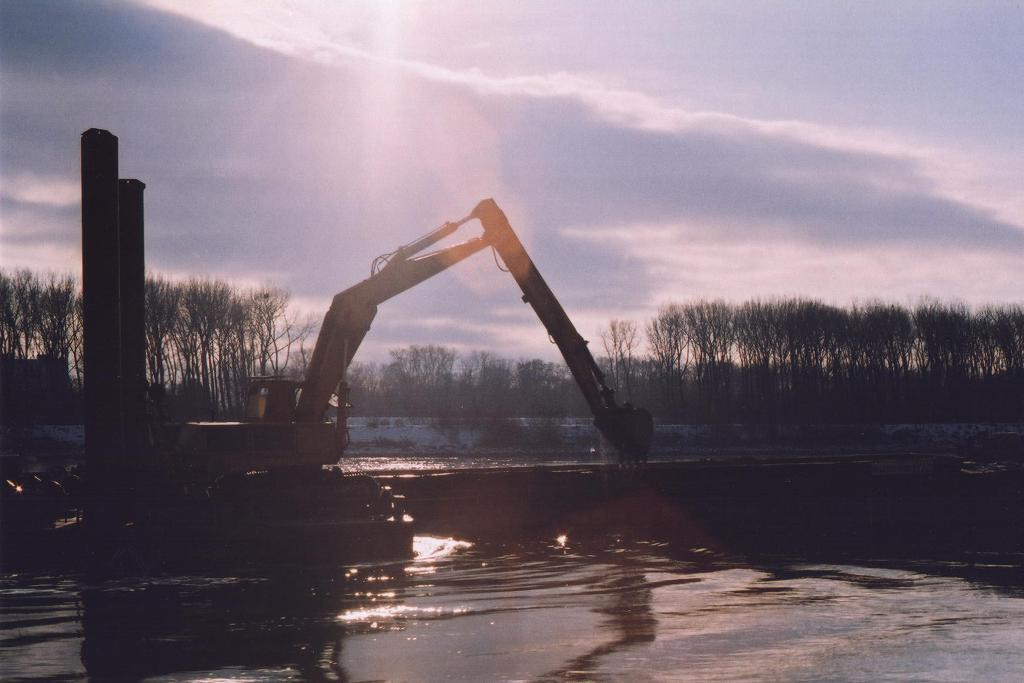What is the main subject in the center of the image? There is a crane in the center of the image. What can be seen in the background of the image? There are trees in the background of the image. What is visible in the sky at the top of the image? There are clouds in the sky at the top of the image. What is visible at the bottom of the image? There is water visible at the bottom of the image. What type of curtain is hanging in front of the crane in the image? There is no curtain present in the image; it features a crane, trees, clouds, and water. 